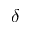Convert formula to latex. <formula><loc_0><loc_0><loc_500><loc_500>\delta</formula> 